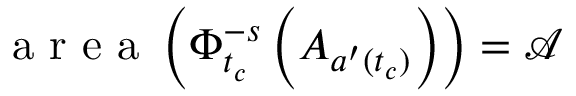Convert formula to latex. <formula><loc_0><loc_0><loc_500><loc_500>a r e a \left ( \Phi _ { t _ { c } } ^ { - s } \left ( A _ { a ^ { \prime } ( t _ { c } ) } \right ) \right ) = \mathcal { A }</formula> 